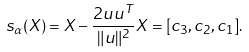<formula> <loc_0><loc_0><loc_500><loc_500>s _ { \alpha } ( X ) = X - \frac { 2 u u ^ { T } } { \| u \| ^ { 2 } } X = [ c _ { 3 } , c _ { 2 } , c _ { 1 } ] .</formula> 